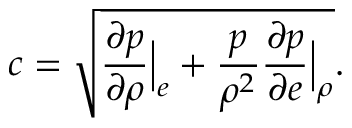Convert formula to latex. <formula><loc_0><loc_0><loc_500><loc_500>c = \sqrt { \frac { \partial p } { \partial \rho } \left | _ { e } + \frac { p } { \rho ^ { 2 } } \frac { \partial p } { \partial e } \right | _ { \rho } } .</formula> 